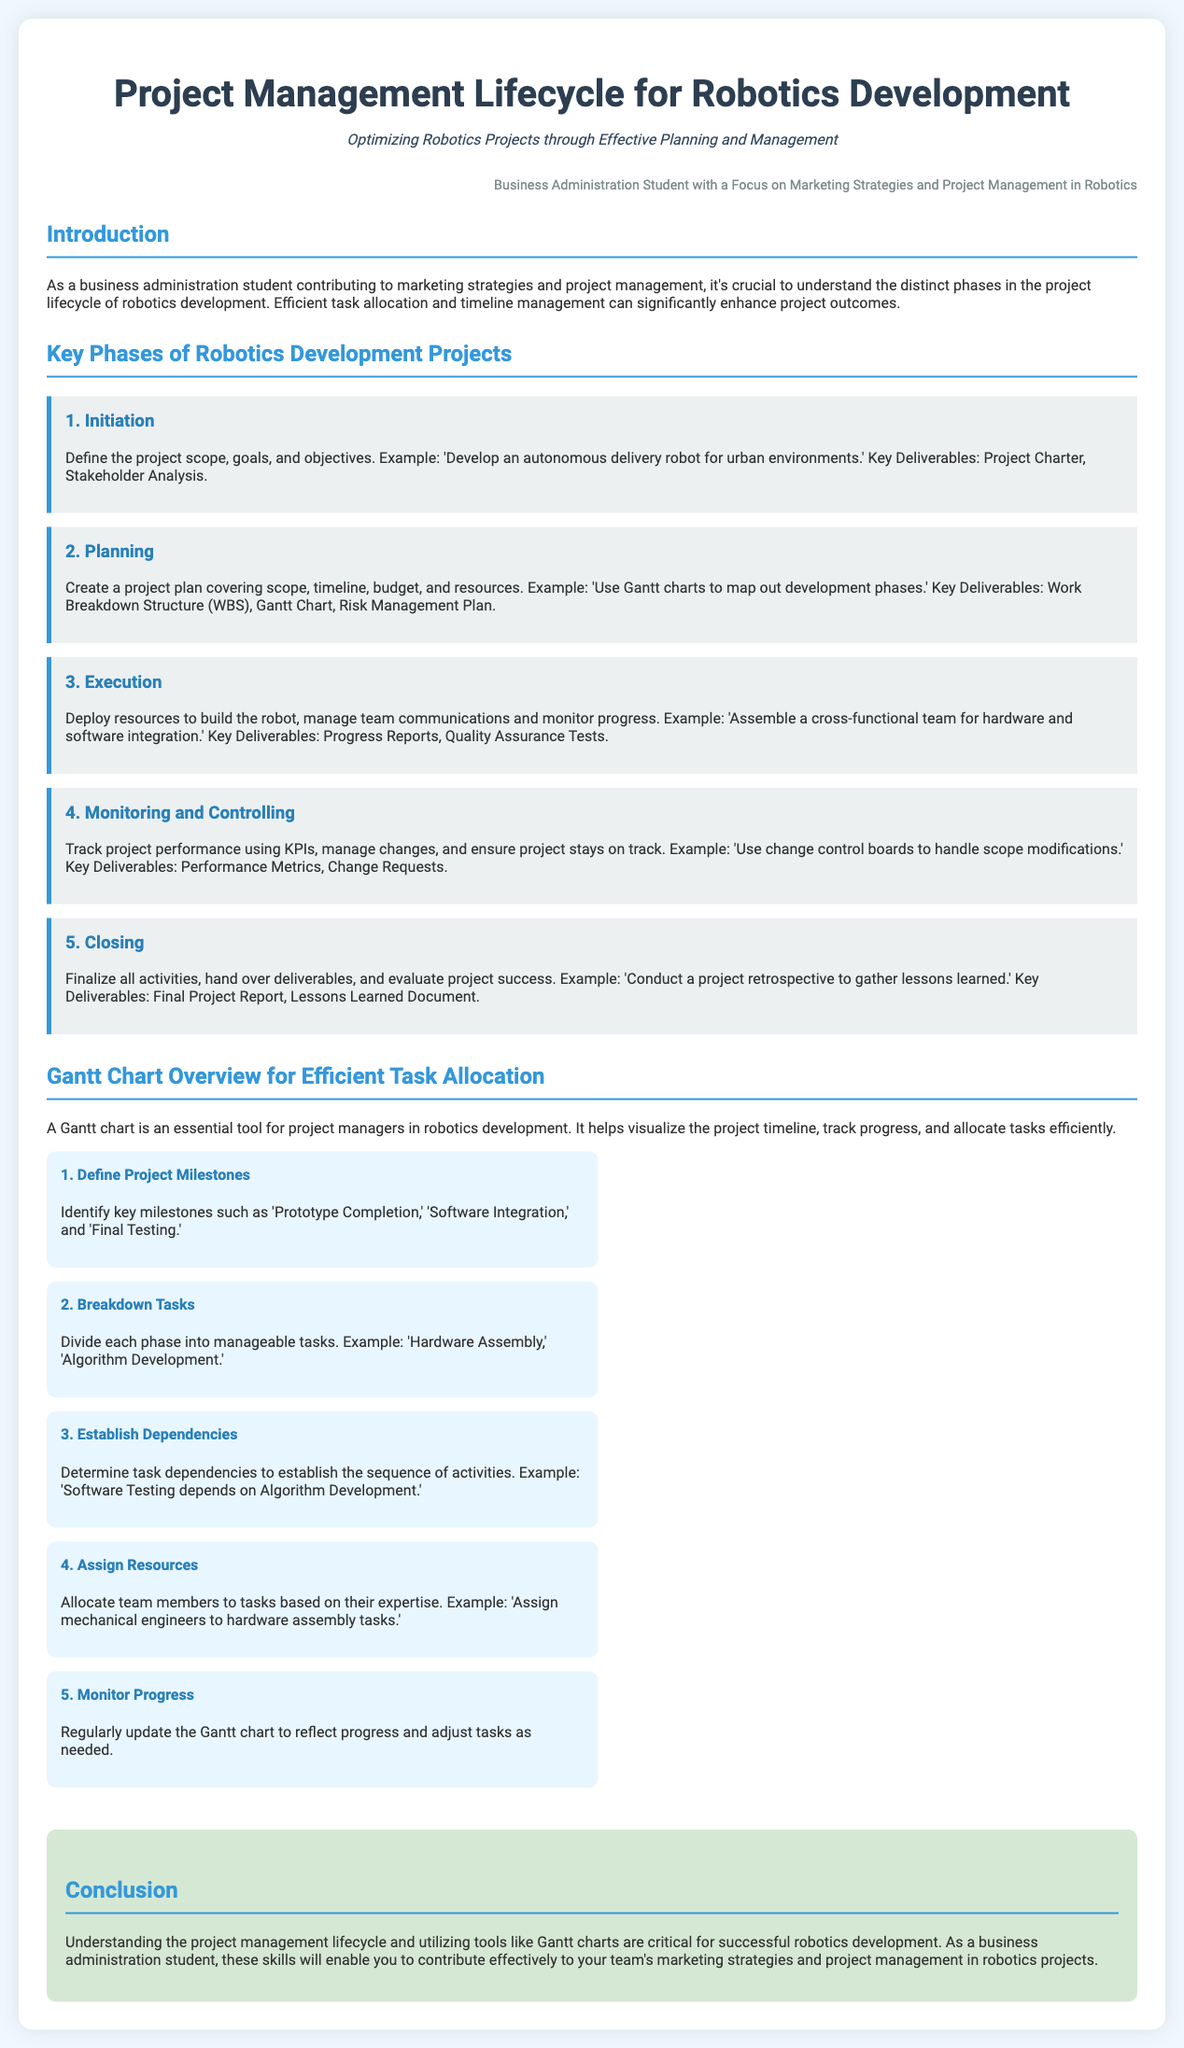What are the key phases of robotics development? The document outlines five key phases: Initiation, Planning, Execution, Monitoring and Controlling, and Closing.
Answer: Initiation, Planning, Execution, Monitoring and Controlling, Closing What is a crucial tool for project managers in robotics development? The document emphasizes that a Gantt chart is essential for visualizing the project timeline and task allocation.
Answer: Gantt chart What key deliverable is associated with the planning phase? The planning phase mentions several deliverables, among which the Gantt Chart is specifically highlighted as significant.
Answer: Gantt Chart How many steps are outlined in the Gantt chart overview for task allocation? The document lists five steps in the Gantt chart overview for efficient task allocation.
Answer: 5 What is a recommended action in the execution phase for team communication? The document suggests managing team communications as part of resource deployment during execution.
Answer: Manage team communications What example is provided for the Initiation phase? The document presents 'Develop an autonomous delivery robot for urban environments' as an example in the Initiation phase.
Answer: Develop an autonomous delivery robot for urban environments What should be established to determine the tasks’ sequence? The document mentions that establishing dependencies is crucial for determining the sequence of tasks.
Answer: Establish dependencies Which phase includes conducting a project retrospective? The closing phase of the project lifecycle involves conducting a project retrospective to gather lessons learned.
Answer: Closing 